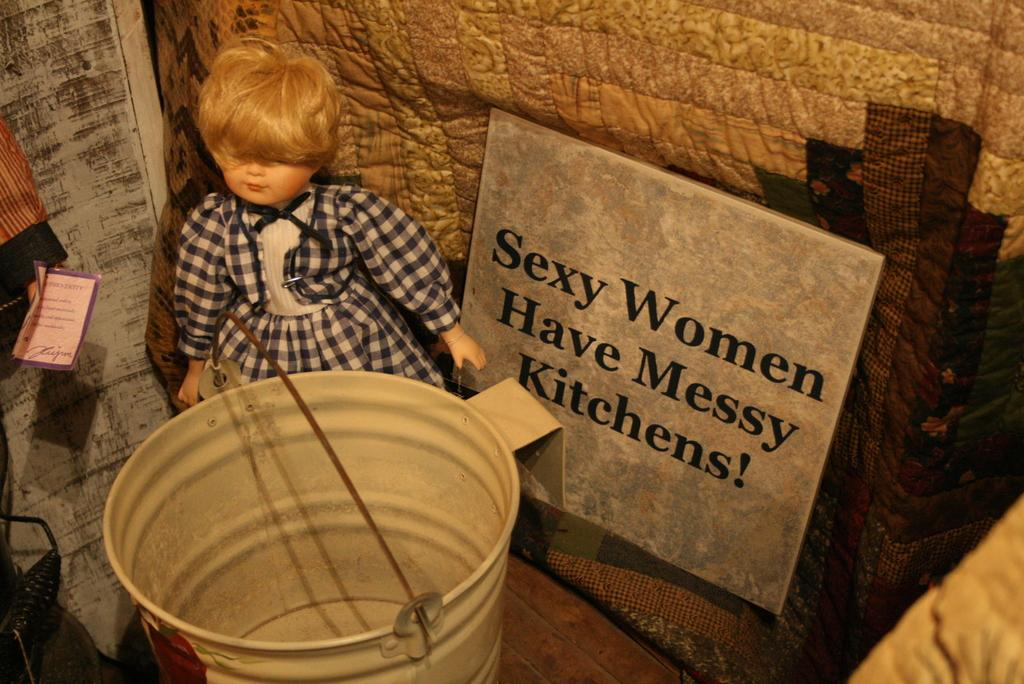What is the main object in the image? There is a doll in the image. What other objects can be seen in the image? There is a bucket and a name board in the image. What type of material is the wall made of? There is a wooden wall in the image. What type of vegetable is growing on the wooden wall in the image? There are no vegetables growing on the wooden wall in the image. Can you describe the taste of the doll in the image? The doll is not an edible object, so it does not have a taste. 